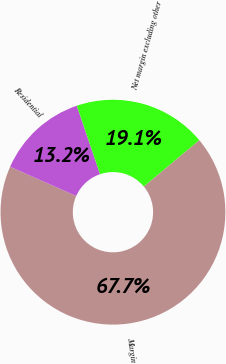<chart> <loc_0><loc_0><loc_500><loc_500><pie_chart><fcel>Margin<fcel>Residential<fcel>Net margin excluding other<nl><fcel>67.7%<fcel>13.17%<fcel>19.13%<nl></chart> 